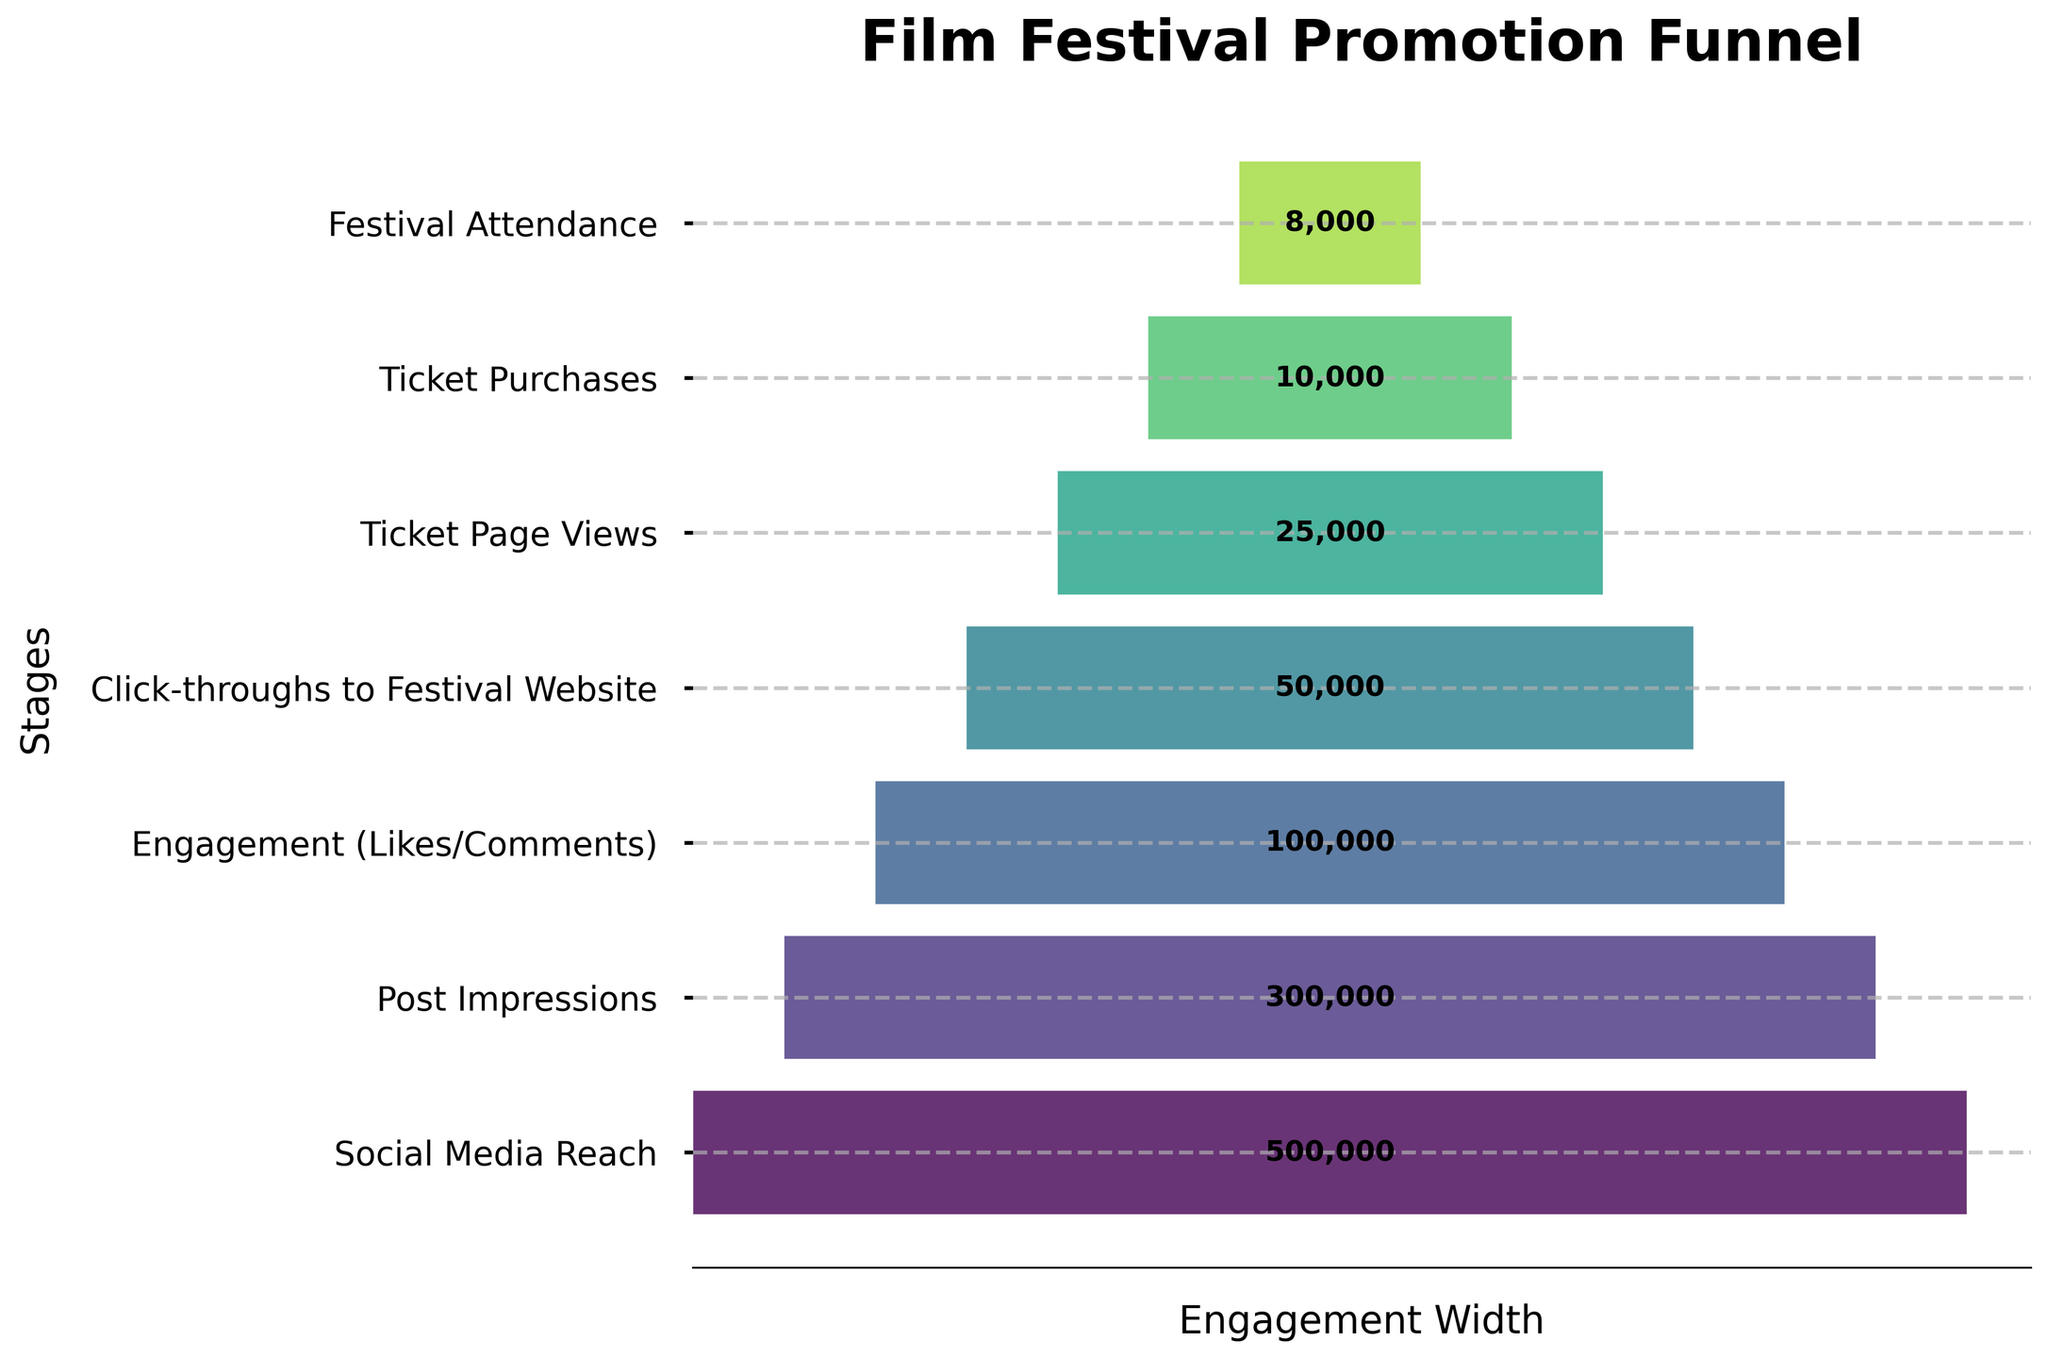What is the title of the funnel chart? The title of the funnel chart is displayed prominently at the top of the figure. It reads "Film Festival Promotion Funnel."
Answer: Film Festival Promotion Funnel How many stages are shown in the funnel chart? The funnel chart shows the different stages from social media reach to festival attendance. Counting these stages, there are 7.
Answer: 7 What is the count for 'Ticket Purchases'? The funnel chart includes labels for each stage. The count for the 'Ticket Purchases' stage is displayed in the center of that segment and reads 10,000.
Answer: 10,000 Which stage has the highest count? By looking at the funnel chart, the first stage 'Social Media Reach' has the largest width, and the labeled count is 500,000.
Answer: Social Media Reach What is the difference in count between 'Post Impressions' and 'Click-throughs to Festival Website'? The count for 'Post Impressions' is 300,000 and for 'Click-throughs to Festival Website' is 50,000. Subtracting the two gives 300,000 - 50,000 = 250,000.
Answer: 250,000 What is the average count across all stages? To find the average count, sum up all the stage counts (500,000 + 300,000 + 100,000 + 50,000 + 25,000 + 10,000 + 8,000 = 993,000) and divide by the number of stages (7). So, the average count is 993,000 / 7 ≈ 141,857.14.
Answer: 141,857.14 How does the count for 'Engagement (Likes/Comments)' compare to 'Ticket Page Views'? The count for 'Engagement (Likes/Comments)' is 100,000, while the count for 'Ticket Page Views' is 25,000. Thus, 'Engagement (Likes/Comments)' is 75,000 higher than 'Ticket Page Views'.
Answer: 75,000 higher Is the drop-off between 'Social Media Reach' and 'Post Impressions' more significant than the drop-off between 'Click-throughs to Festival Website' and 'Ticket Page Views'? The drop-off from 'Social Media Reach' to 'Post Impressions' is 500,000 - 300,000 = 200,000. The drop-off from 'Click-throughs to Festival Website' to 'Ticket Page Views' is 50,000 - 25,000 = 25,000. Therefore, the former drop-off is more significant at 200,000.
Answer: Yes What is the ratio of 'Ticket Purchases' to 'Social Media Reach'? The count for 'Ticket Purchases' is 10,000 and for 'Social Media Reach' is 500,000. The ratio is 10,000 / 500,000, which simplifies to 1:50.
Answer: 1:50 